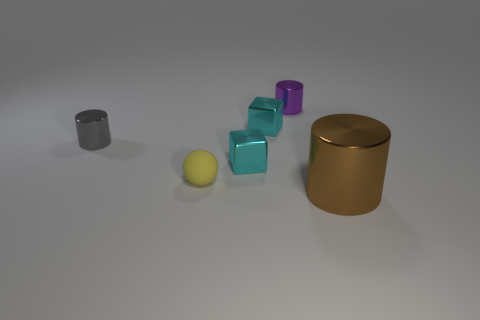Could you suggest what these objects might be used for if they were real? If these objects were real, they could serve multiple purposes. The cylinders might be containers for holding items or decorative pieces due to their sleek design. The cubes could be paperweights, educational tools for children, or even components of a larger installation or game. 